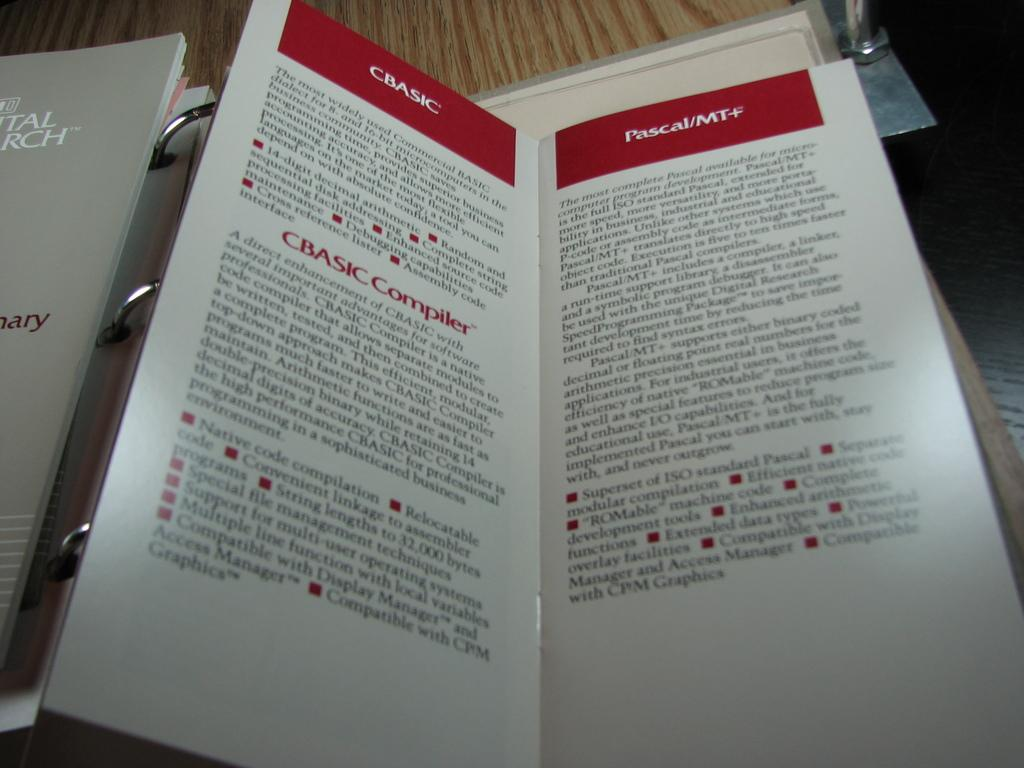<image>
Present a compact description of the photo's key features. A Pumphelet of CBASIC shows some details about it. 